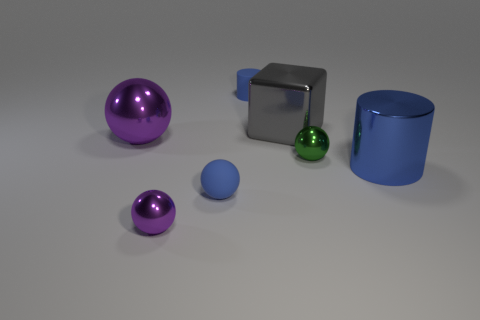There is a blue cylinder behind the cylinder that is in front of the small rubber cylinder; is there a blue metallic cylinder that is in front of it?
Keep it short and to the point. Yes. The other matte thing that is the same shape as the large purple object is what color?
Your answer should be very brief. Blue. What number of blue things are tiny cylinders or rubber balls?
Your answer should be compact. 2. The purple ball behind the metallic sphere in front of the small blue sphere is made of what material?
Offer a terse response. Metal. Is the shape of the tiny green object the same as the large purple metallic thing?
Your response must be concise. Yes. The cube that is the same size as the blue metallic thing is what color?
Offer a terse response. Gray. Is there a small matte cylinder of the same color as the big shiny cylinder?
Give a very brief answer. Yes. Are there any yellow rubber cylinders?
Provide a succinct answer. No. Is the material of the purple object in front of the large blue shiny cylinder the same as the green sphere?
Your answer should be very brief. Yes. What size is the metal cylinder that is the same color as the tiny rubber sphere?
Ensure brevity in your answer.  Large. 